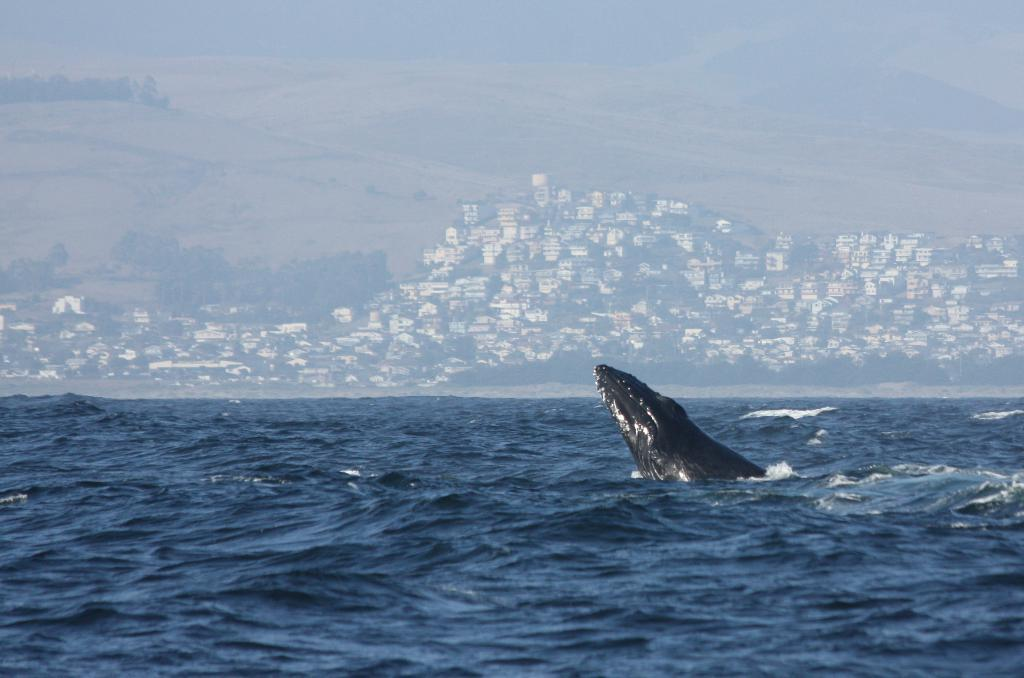What type of animal is in the image? There is a marine animal in the image. Where is the marine animal located? The marine animal is in the water. What can be seen in the background of the image? There are buildings in the background of the image. Can you tell me how many pictures are hanging on the wall in the image? There is no mention of any pictures or walls in the image; it features a marine animal in the water with buildings in the background. 